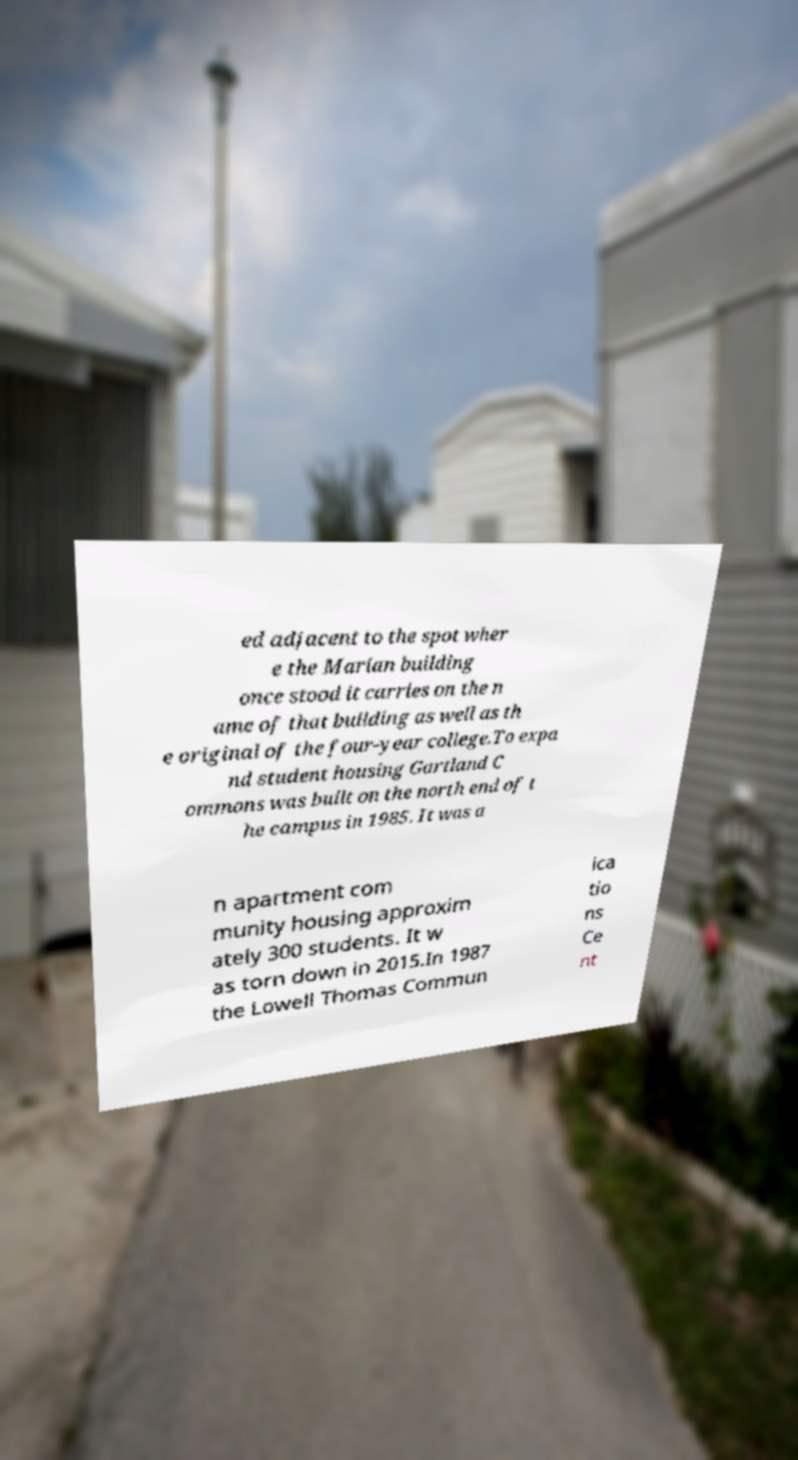What messages or text are displayed in this image? I need them in a readable, typed format. ed adjacent to the spot wher e the Marian building once stood it carries on the n ame of that building as well as th e original of the four-year college.To expa nd student housing Gartland C ommons was built on the north end of t he campus in 1985. It was a n apartment com munity housing approxim ately 300 students. It w as torn down in 2015.In 1987 the Lowell Thomas Commun ica tio ns Ce nt 